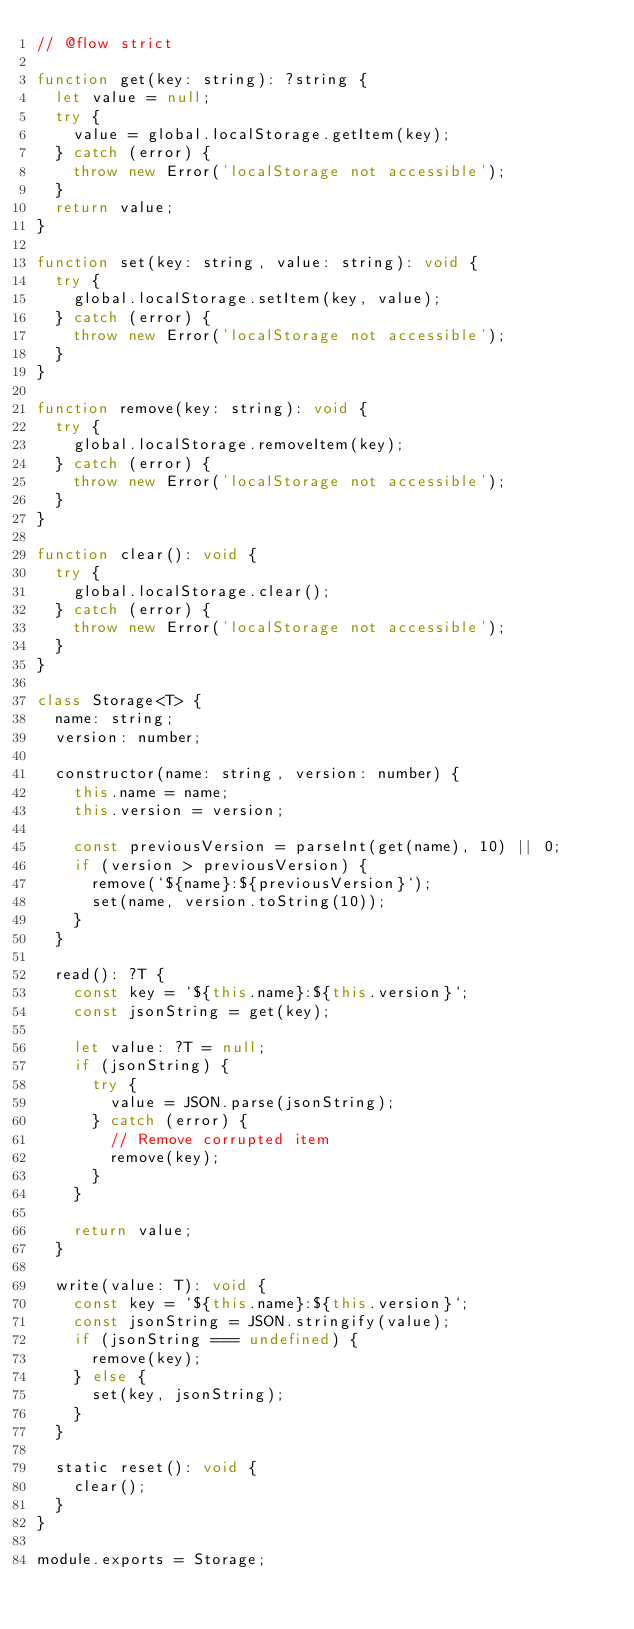<code> <loc_0><loc_0><loc_500><loc_500><_JavaScript_>// @flow strict

function get(key: string): ?string {
  let value = null;
  try {
    value = global.localStorage.getItem(key);
  } catch (error) {
    throw new Error('localStorage not accessible');
  }
  return value;
}

function set(key: string, value: string): void {
  try {
    global.localStorage.setItem(key, value);
  } catch (error) {
    throw new Error('localStorage not accessible');
  }
}

function remove(key: string): void {
  try {
    global.localStorage.removeItem(key);
  } catch (error) {
    throw new Error('localStorage not accessible');
  }
}

function clear(): void {
  try {
    global.localStorage.clear();
  } catch (error) {
    throw new Error('localStorage not accessible');
  }
}

class Storage<T> {
  name: string;
  version: number;

  constructor(name: string, version: number) {
    this.name = name;
    this.version = version;

    const previousVersion = parseInt(get(name), 10) || 0;
    if (version > previousVersion) {
      remove(`${name}:${previousVersion}`);
      set(name, version.toString(10));
    }
  }

  read(): ?T {
    const key = `${this.name}:${this.version}`;
    const jsonString = get(key);

    let value: ?T = null;
    if (jsonString) {
      try {
        value = JSON.parse(jsonString);
      } catch (error) {
        // Remove corrupted item
        remove(key);
      }
    }

    return value;
  }

  write(value: T): void {
    const key = `${this.name}:${this.version}`;
    const jsonString = JSON.stringify(value);
    if (jsonString === undefined) {
      remove(key);
    } else {
      set(key, jsonString);
    }
  }

  static reset(): void {
    clear();
  }
}

module.exports = Storage;
</code> 